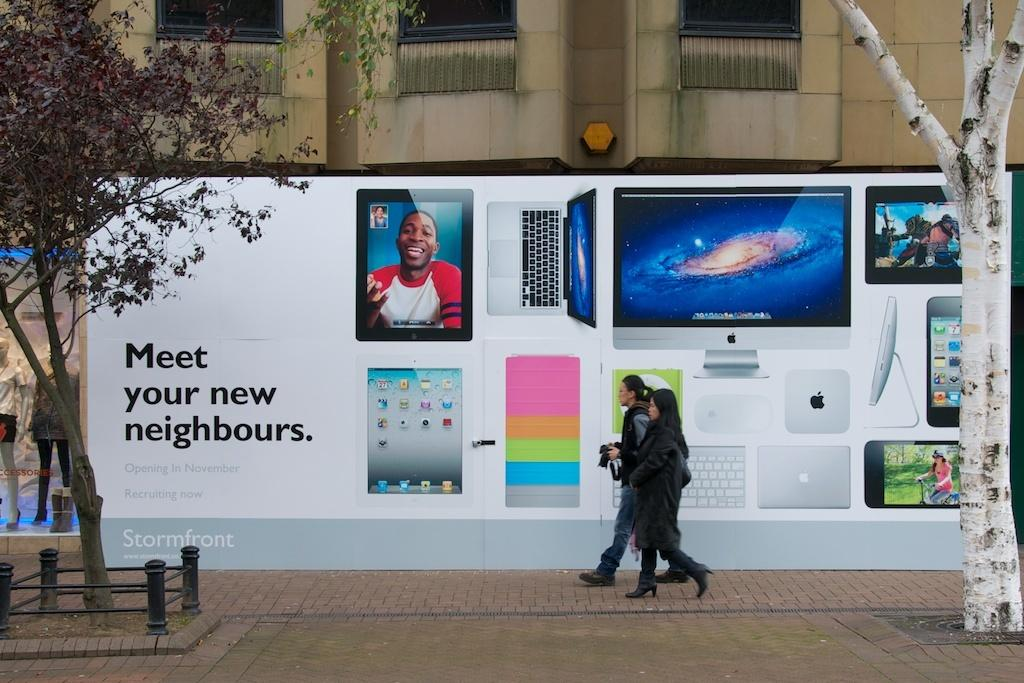Provide a one-sentence caption for the provided image. Two women walking infront of a billboard that says Meet your new neighbours. 